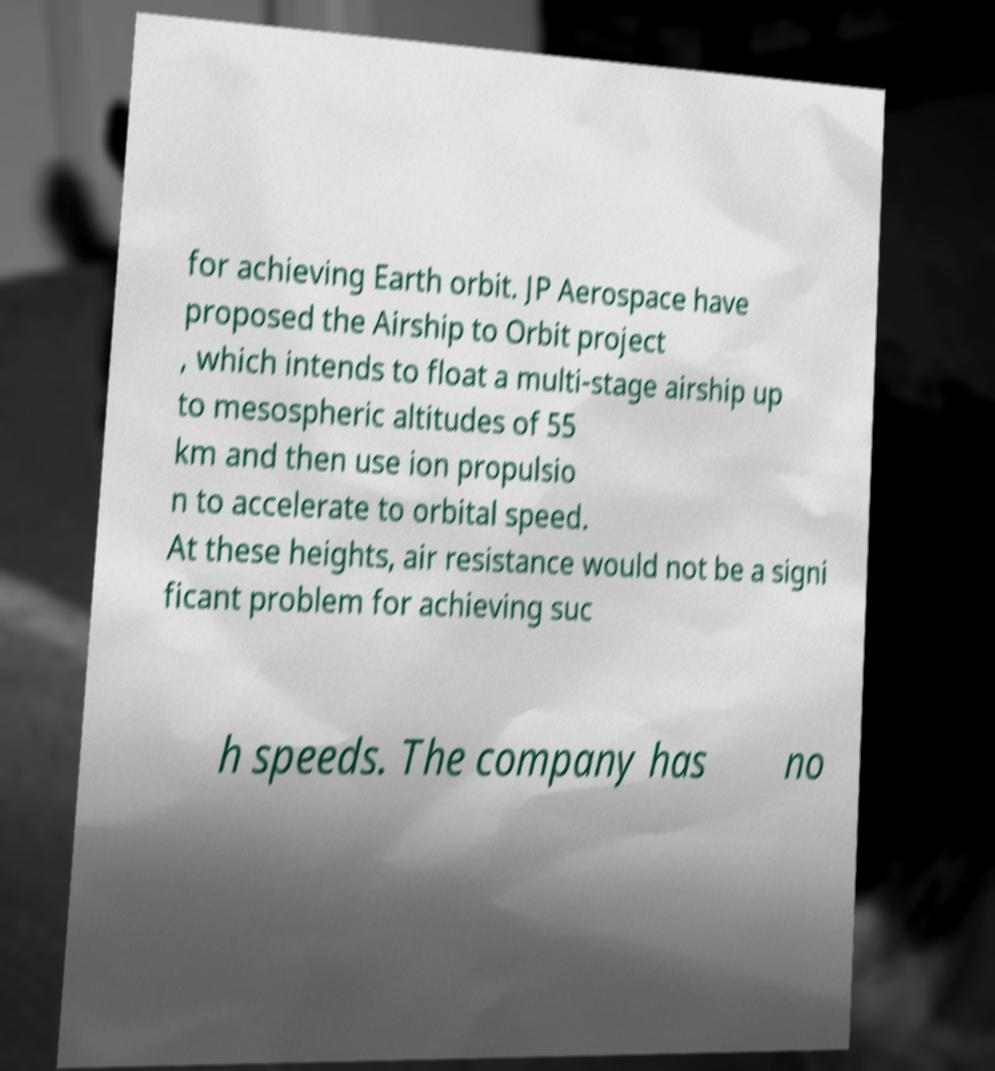Please identify and transcribe the text found in this image. for achieving Earth orbit. JP Aerospace have proposed the Airship to Orbit project , which intends to float a multi-stage airship up to mesospheric altitudes of 55 km and then use ion propulsio n to accelerate to orbital speed. At these heights, air resistance would not be a signi ficant problem for achieving suc h speeds. The company has no 